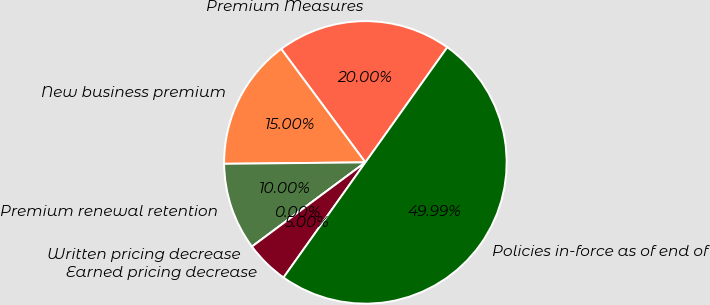<chart> <loc_0><loc_0><loc_500><loc_500><pie_chart><fcel>Premium Measures<fcel>New business premium<fcel>Premium renewal retention<fcel>Written pricing decrease<fcel>Earned pricing decrease<fcel>Policies in-force as of end of<nl><fcel>20.0%<fcel>15.0%<fcel>10.0%<fcel>0.0%<fcel>5.0%<fcel>49.99%<nl></chart> 